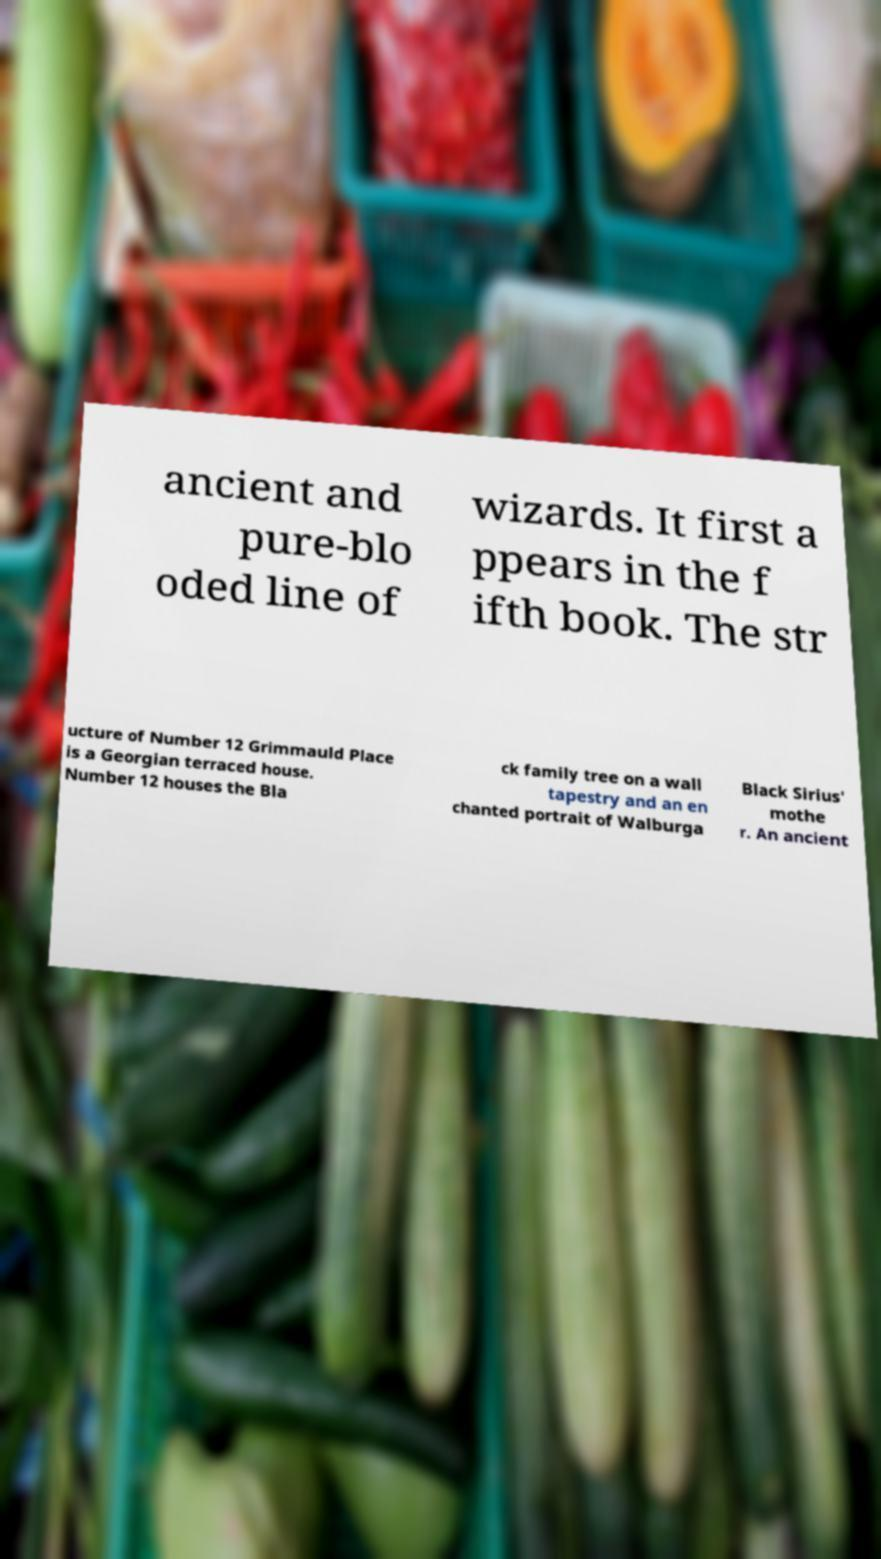There's text embedded in this image that I need extracted. Can you transcribe it verbatim? ancient and pure-blo oded line of wizards. It first a ppears in the f ifth book. The str ucture of Number 12 Grimmauld Place is a Georgian terraced house. Number 12 houses the Bla ck family tree on a wall tapestry and an en chanted portrait of Walburga Black Sirius' mothe r. An ancient 